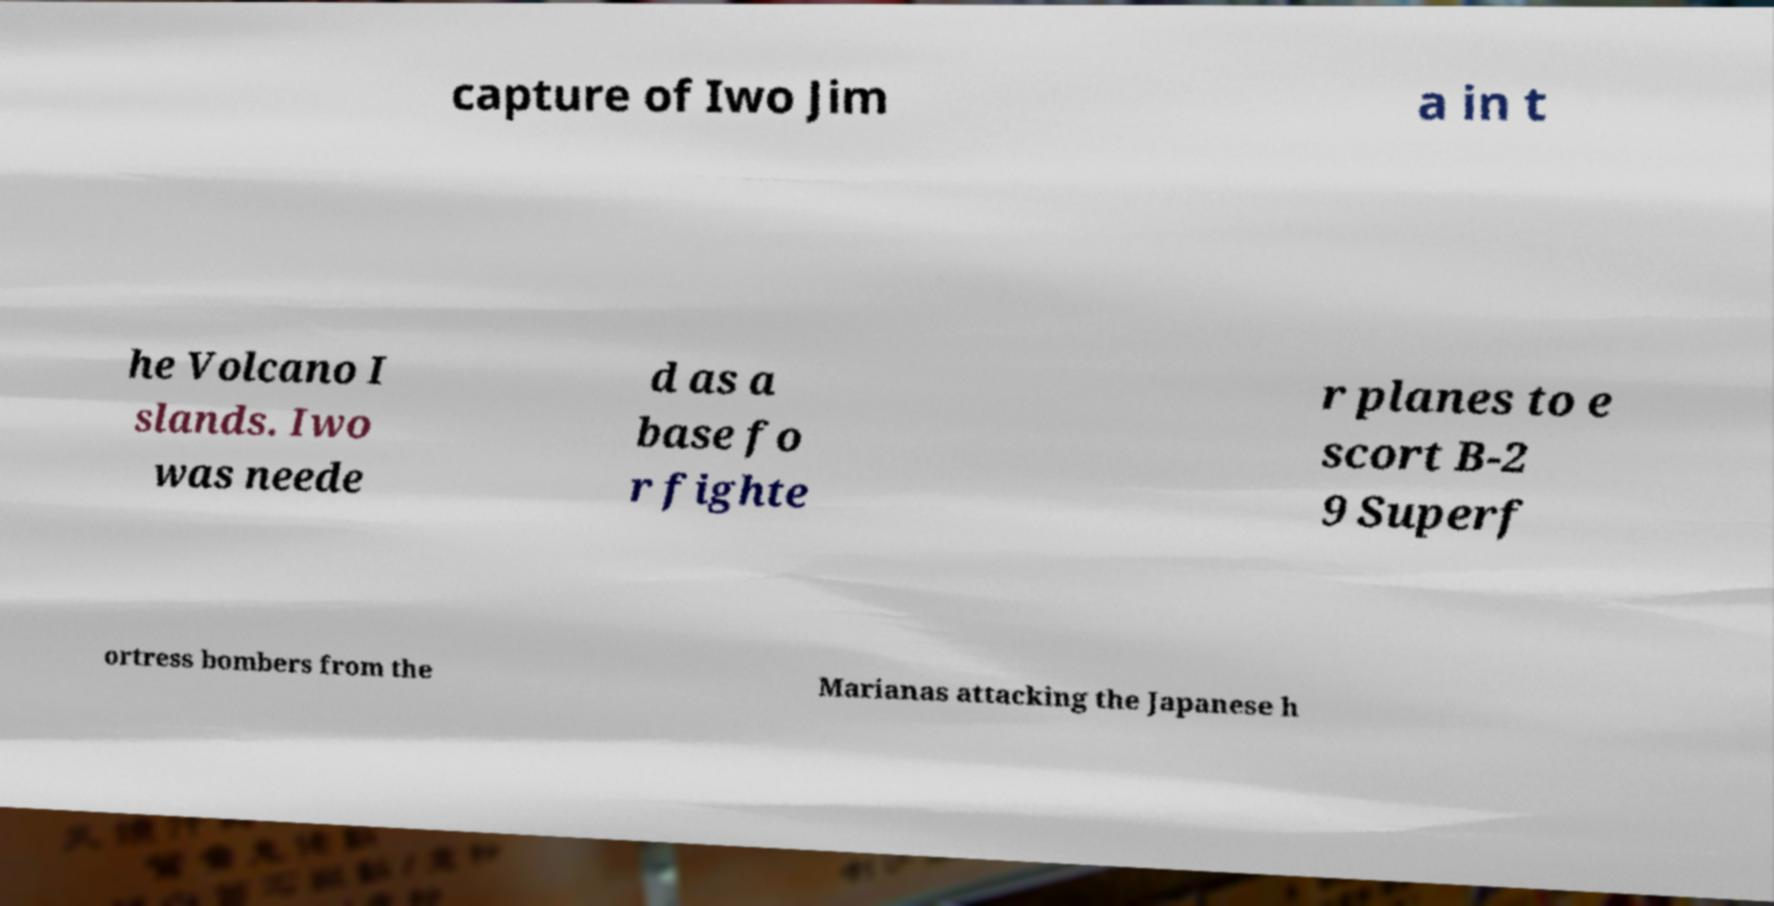There's text embedded in this image that I need extracted. Can you transcribe it verbatim? capture of Iwo Jim a in t he Volcano I slands. Iwo was neede d as a base fo r fighte r planes to e scort B-2 9 Superf ortress bombers from the Marianas attacking the Japanese h 